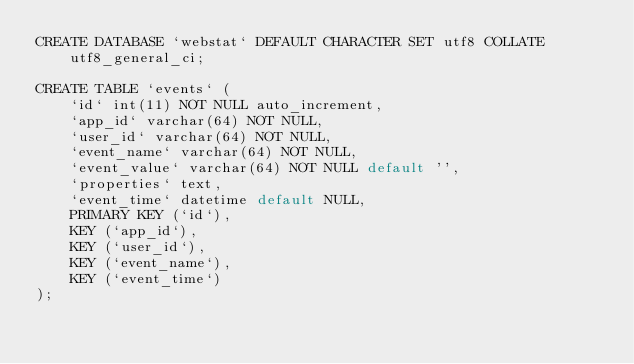<code> <loc_0><loc_0><loc_500><loc_500><_SQL_>CREATE DATABASE `webstat` DEFAULT CHARACTER SET utf8 COLLATE utf8_general_ci;

CREATE TABLE `events` (
    `id` int(11) NOT NULL auto_increment,
    `app_id` varchar(64) NOT NULL,
    `user_id` varchar(64) NOT NULL,
    `event_name` varchar(64) NOT NULL,
    `event_value` varchar(64) NOT NULL default '',
    `properties` text,
    `event_time` datetime default NULL,
    PRIMARY KEY (`id`),
    KEY (`app_id`),
    KEY (`user_id`),
    KEY (`event_name`),
    KEY (`event_time`)
);
</code> 